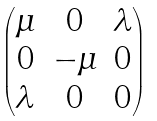Convert formula to latex. <formula><loc_0><loc_0><loc_500><loc_500>\begin{pmatrix} \mu & 0 & \lambda \\ 0 & - \mu & 0 \\ \lambda & 0 & 0 \end{pmatrix}</formula> 